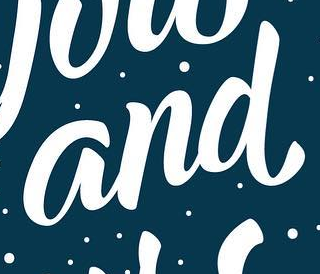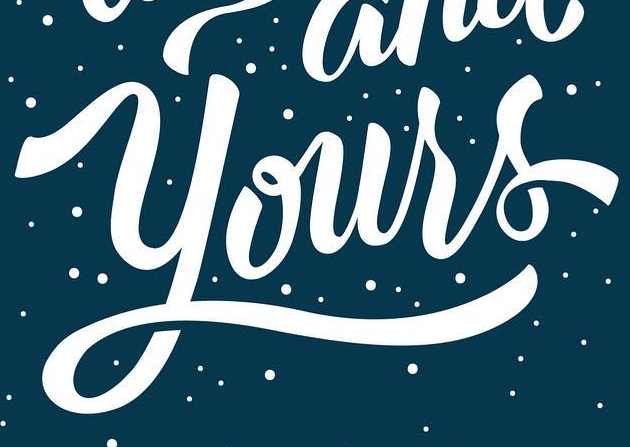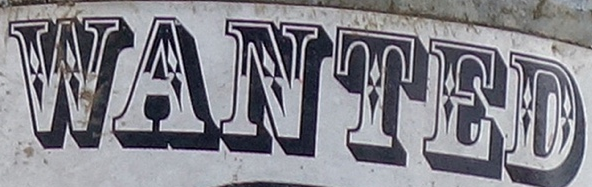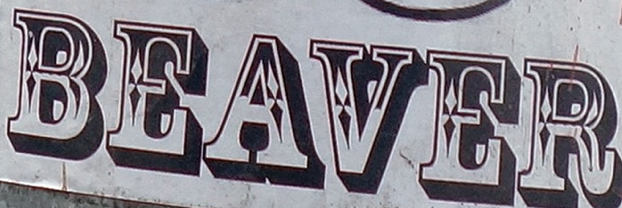What words are shown in these images in order, separated by a semicolon? and; Yours; WANTED; BEAVER 